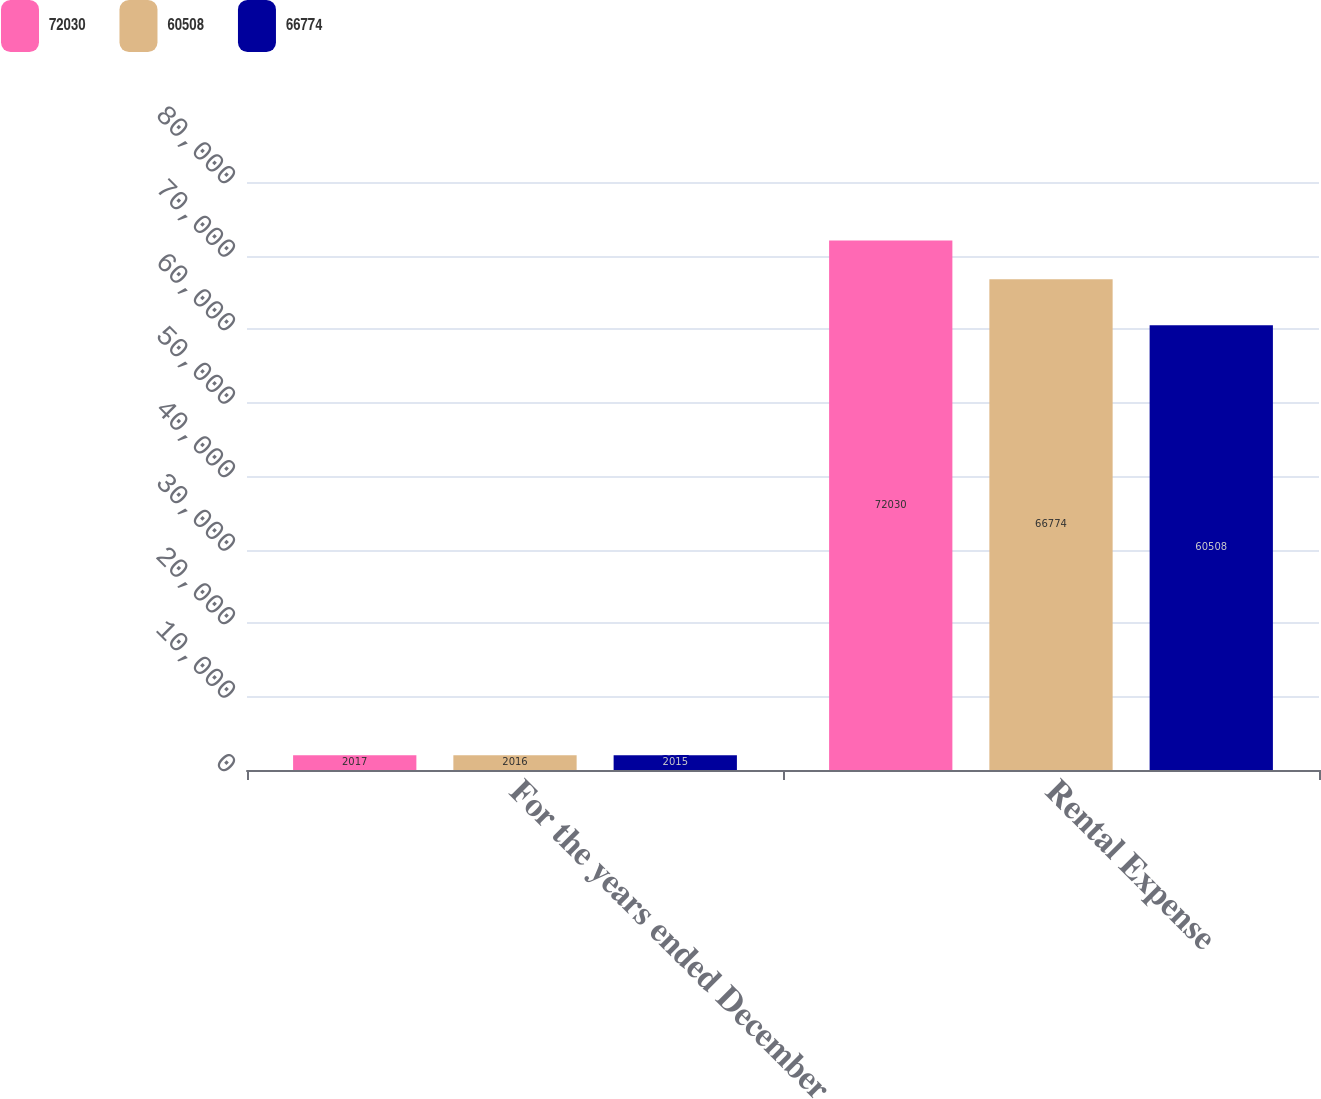Convert chart to OTSL. <chart><loc_0><loc_0><loc_500><loc_500><stacked_bar_chart><ecel><fcel>For the years ended December<fcel>Rental Expense<nl><fcel>72030<fcel>2017<fcel>72030<nl><fcel>60508<fcel>2016<fcel>66774<nl><fcel>66774<fcel>2015<fcel>60508<nl></chart> 